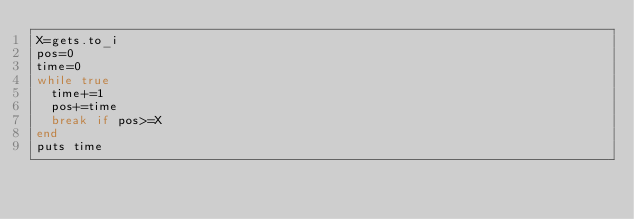<code> <loc_0><loc_0><loc_500><loc_500><_Ruby_>X=gets.to_i
pos=0
time=0
while true
  time+=1
  pos+=time
  break if pos>=X
end
puts time</code> 